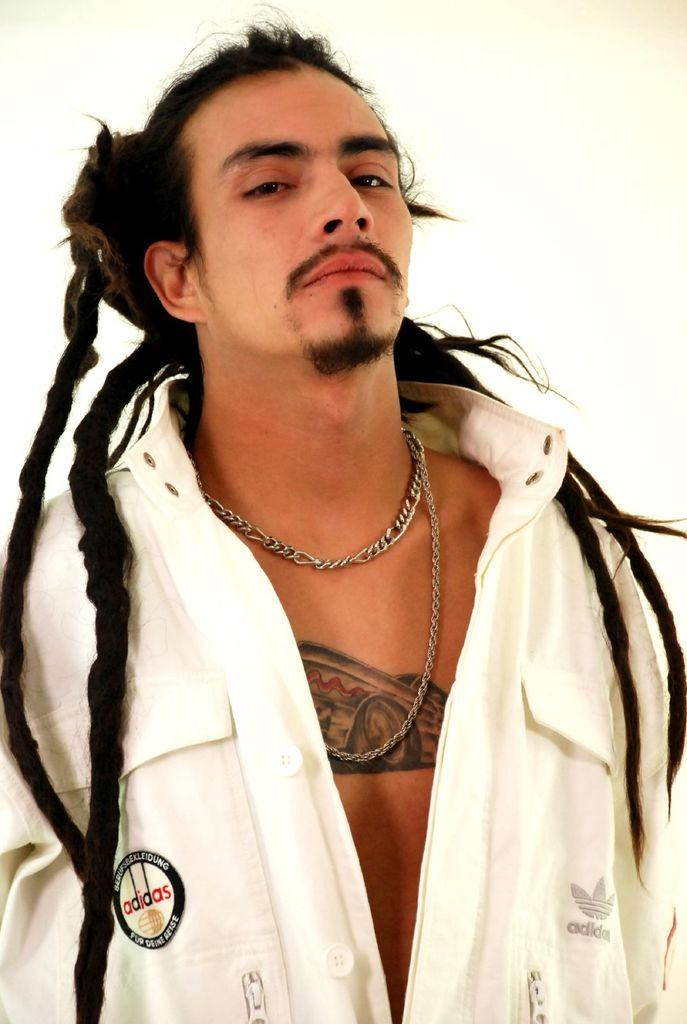What is the main subject of the image? The main subject of the image is a man. What is the man doing in the image? The man is standing in the image. What is the man wearing in the image? The man is wearing a white color shirt in the image. Are there any additional features or characteristics of the man in the image? Yes, there is a tattoo on the man's body. What type of fork can be seen in the man's hand in the image? There is no fork present in the image; the man is not holding any utensils. 